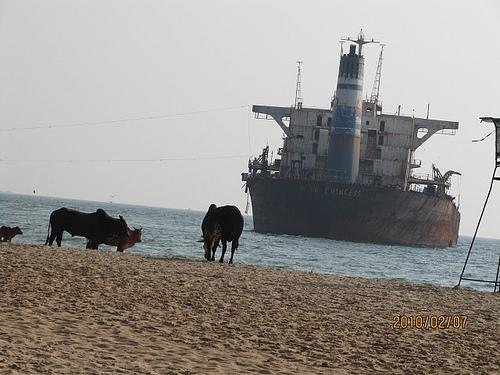What is visible in the water? boat 